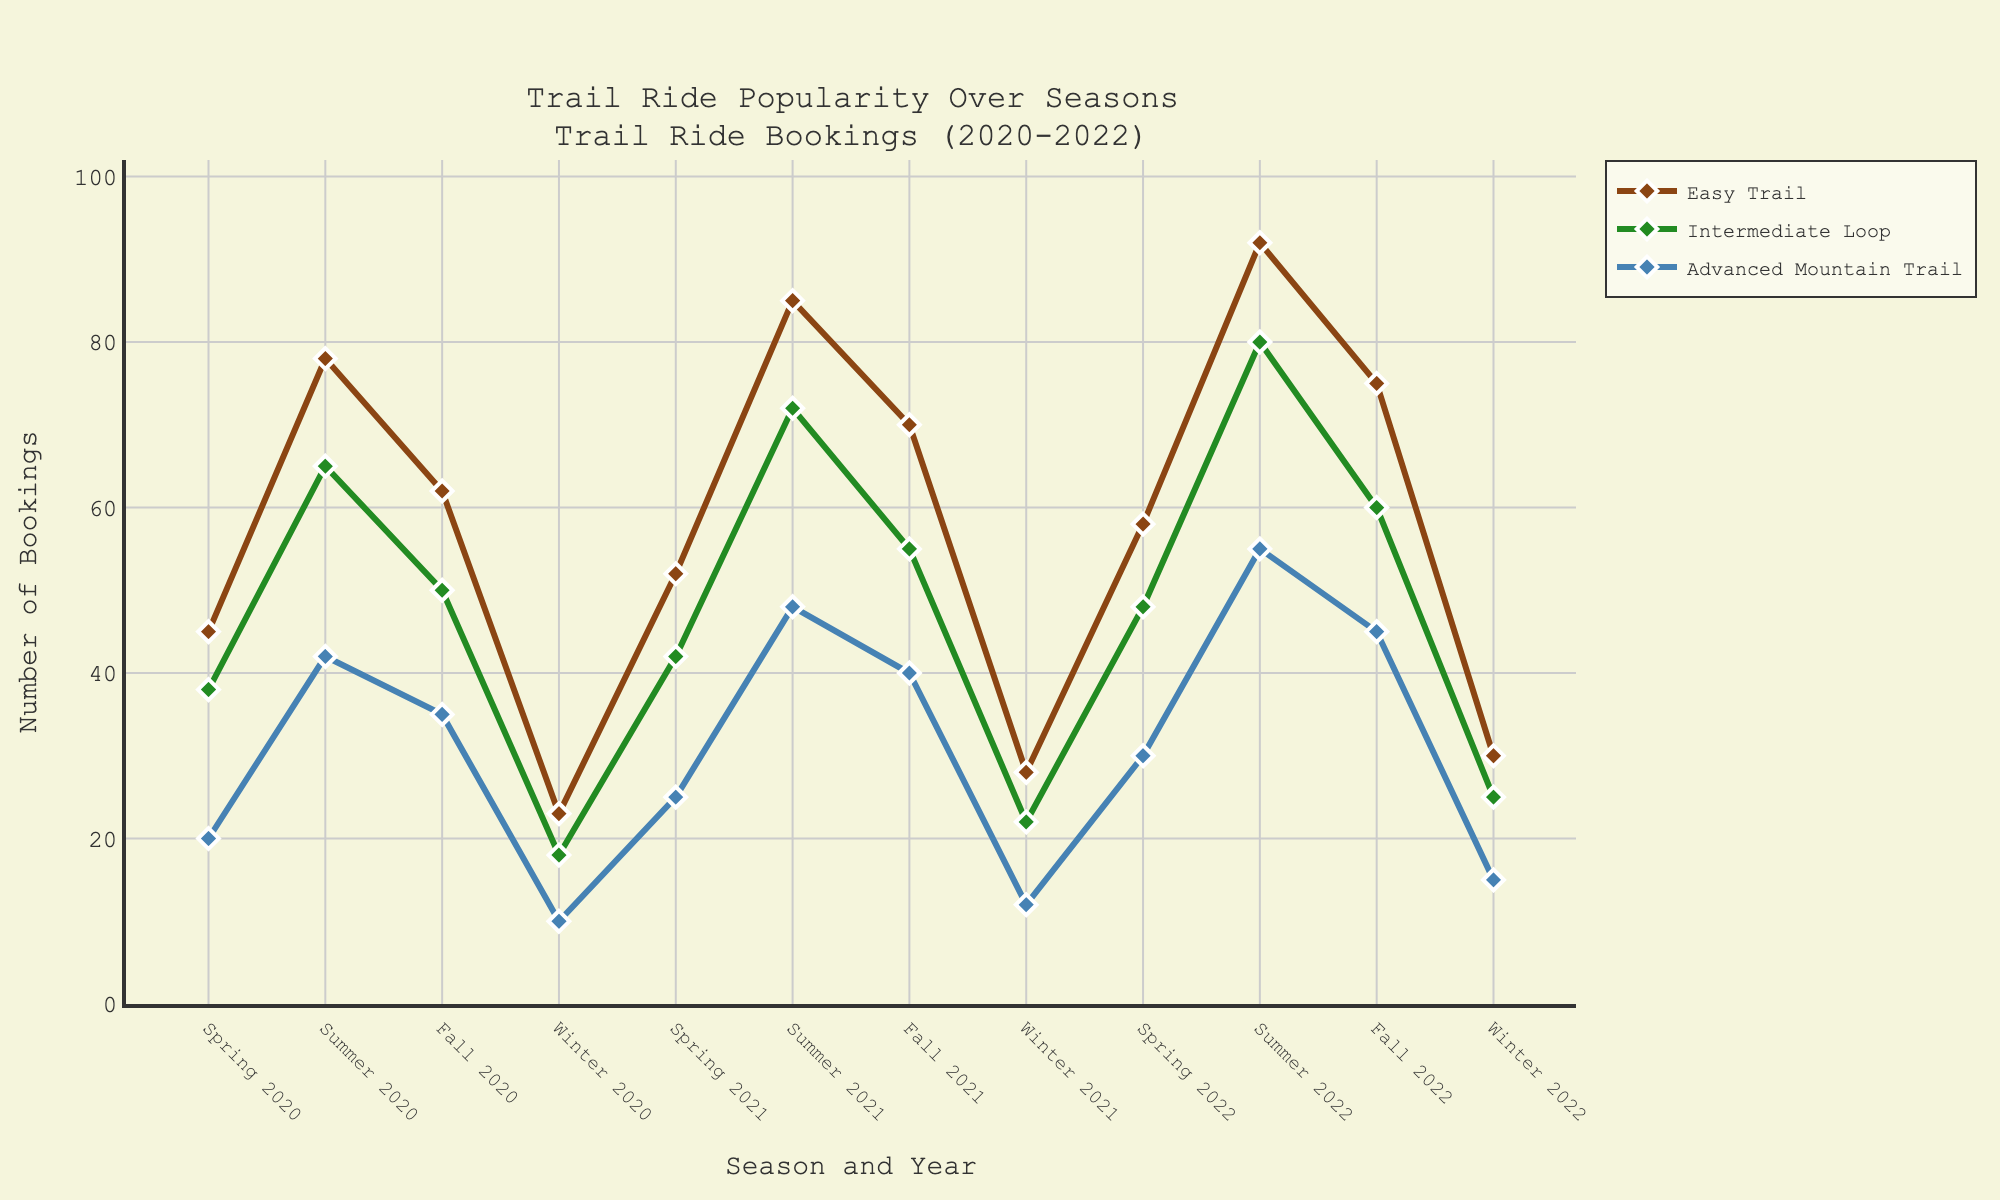Which route had the highest number of bookings in Summer 2022? We need to look at the lines corresponding to each route and compare their peaks in Summer 2022. The "Easy Trail" has the highest point.
Answer: Easy Trail Compare the number of bookings for the "Intermediate Loop" between Winter 2020 and Winter 2022. Which period had more bookings? Look at the data points for "Intermediate Loop" in Winter 2020 and Winter 2022. There are 18 bookings in Winter 2020 and 25 in Winter 2022.
Answer: Winter 2022 What is the average number of bookings for the "Advanced Mountain Trail" during the Fall seasons over the 3-year period? Calculate the average by summing up the bookings for Fall 2020 (35), Fall 2021 (40), and Fall 2022 (45), and then divide by 3. (35 + 40 + 45) / 3 = 120 / 3 = 40
Answer: 40 By how much did the number of bookings for "Easy Trail" in Spring 2022 increase compared to Spring 2020? Subtract the number of bookings in Spring 2020 from Spring 2022 for "Easy Trail". Spring 2022 had 58 bookings and Spring 2020 had 45. The increase is 58 - 45.
Answer: 13 Which route shows the least variation in bookings throughout the 3-year period, based on the visual patterns in the plot? By observing the consistency of the lines, "Advanced Mountain Trail" appears to have less variation as the lines are relatively flatter compared to others.
Answer: Advanced Mountain Trail Which season consistently shows the highest number of bookings for the "Intermediate Loop" over the 3 years? Look for the highest points in each year for the "Intermediate Loop". Summer consistently shows the highest points.
Answer: Summer What is the total number of bookings for the "Easy Trail" in all Winter seasons from 2020 to 2022? Add the bookings for "Easy Trail" in Winter 2020 (23), Winter 2021 (28), and Winter 2022 (30). 23 + 28 + 30 = 81
Answer: 81 Which route had a decreasing trend in bookings from Spring to Winter in a single year? Identify the route where the markers on the line decrease from Spring to Winter within any single year. "Easy Trail" shows this trend in each year.
Answer: Easy Trail What was the change in bookings for the "Intermediate Loop" between Summer 2020 and Summer 2021? Subtract the bookings in Summer 2020 from Summer 2021 for "Intermediate Loop". Summer 2020 had 65 bookings and Summer 2021 had 72 bookings. The change is 72 - 65.
Answer: 7 